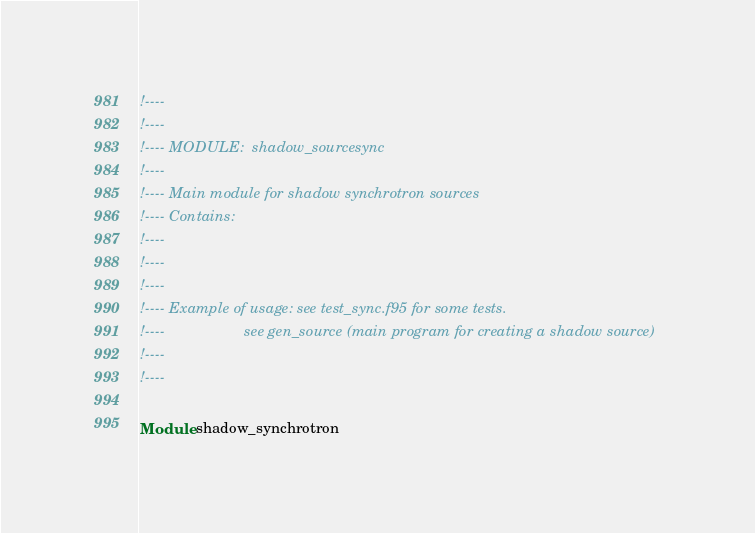<code> <loc_0><loc_0><loc_500><loc_500><_FORTRAN_>!----
!----
!---- MODULE:  shadow_sourcesync
!----
!---- Main module for shadow synchrotron sources
!---- Contains: 
!----
!----
!----
!---- Example of usage: see test_sync.f95 for some tests.
!----                   see gen_source (main program for creating a shadow source)
!----
!----

Module shadow_synchrotron</code> 